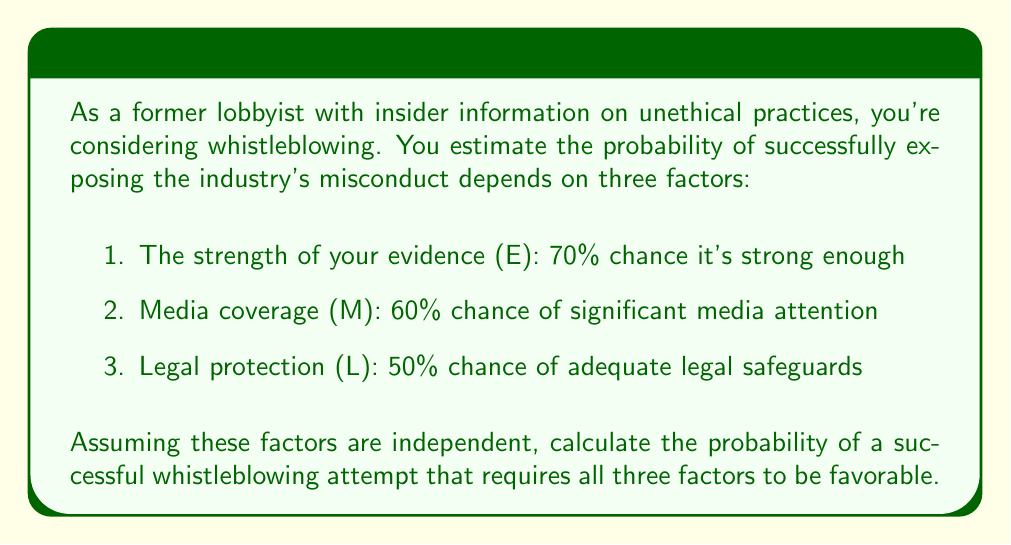Help me with this question. To solve this problem, we need to use the multiplication rule for independent events. Since all three factors need to be favorable for a successful whistleblowing attempt, we multiply the probabilities of each factor:

1. Probability of strong evidence (E): $P(E) = 0.70$
2. Probability of significant media coverage (M): $P(M) = 0.60$
3. Probability of adequate legal protection (L): $P(L) = 0.50$

The probability of all three factors being favorable is:

$$P(\text{Success}) = P(E) \times P(M) \times P(L)$$

Substituting the values:

$$P(\text{Success}) = 0.70 \times 0.60 \times 0.50$$

Calculating:

$$P(\text{Success}) = 0.21$$

To convert to a percentage, multiply by 100:

$$P(\text{Success}) = 0.21 \times 100 = 21\%$$
Answer: The probability of a successful whistleblowing attempt is 21%. 